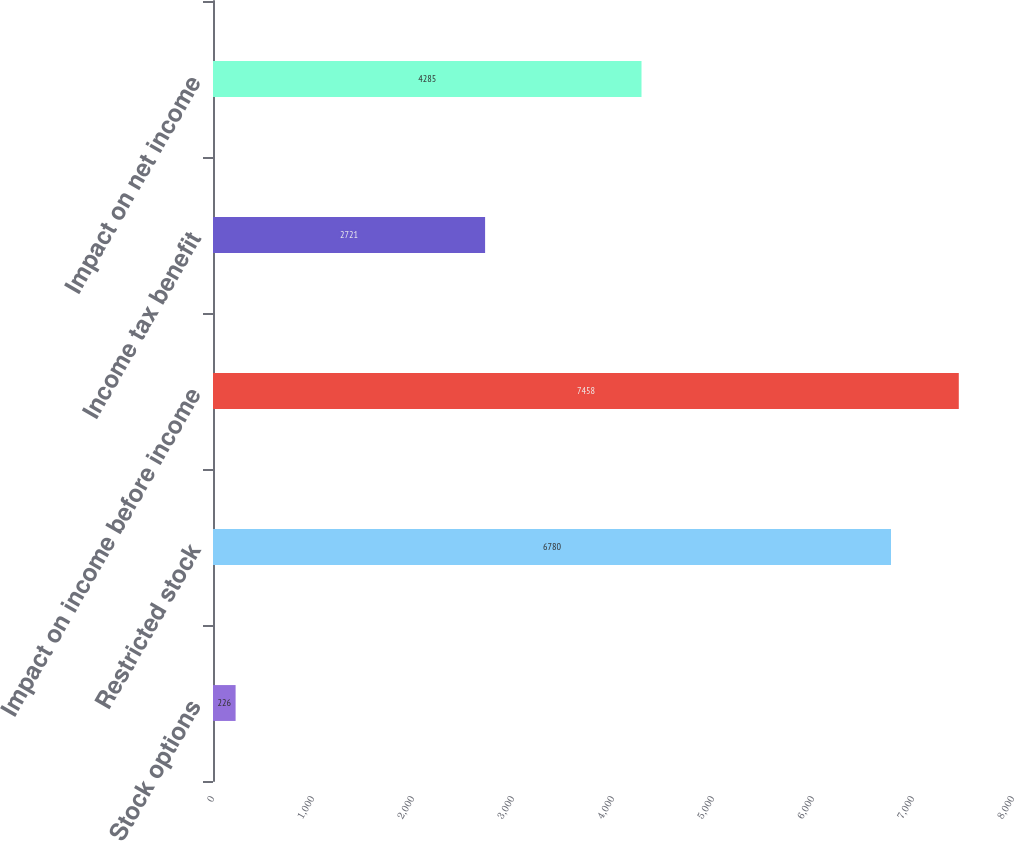Convert chart to OTSL. <chart><loc_0><loc_0><loc_500><loc_500><bar_chart><fcel>Stock options<fcel>Restricted stock<fcel>Impact on income before income<fcel>Income tax benefit<fcel>Impact on net income<nl><fcel>226<fcel>6780<fcel>7458<fcel>2721<fcel>4285<nl></chart> 